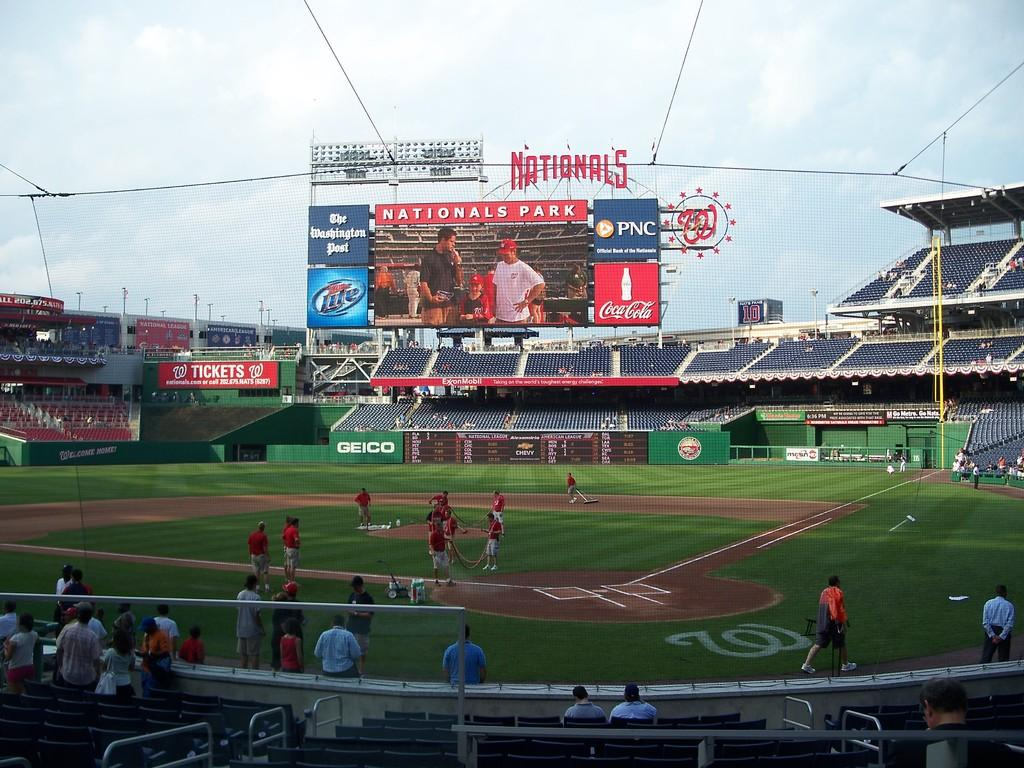<image>
Provide a brief description of the given image. inside the washington nationals baseball park with small number of people 